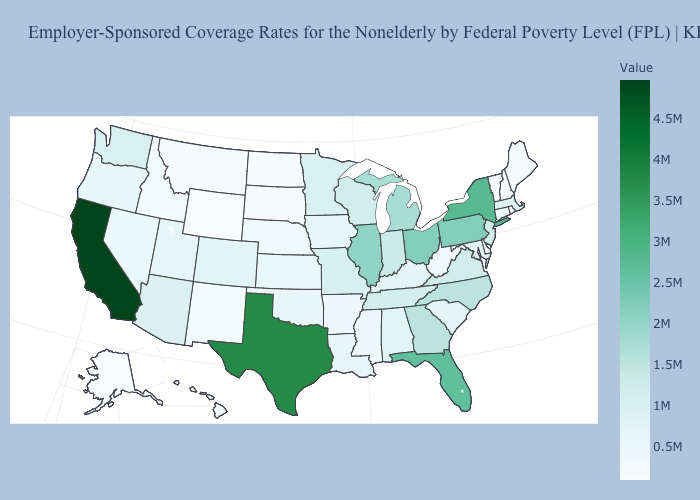Which states have the lowest value in the USA?
Concise answer only. Alaska. Does California have the highest value in the USA?
Quick response, please. Yes. Among the states that border Nevada , does California have the highest value?
Write a very short answer. Yes. Does Alabama have a higher value than Florida?
Be succinct. No. Does North Dakota have the lowest value in the MidWest?
Give a very brief answer. Yes. Does Texas have the highest value in the South?
Be succinct. Yes. Which states have the lowest value in the USA?
Give a very brief answer. Alaska. Does Connecticut have the highest value in the USA?
Write a very short answer. No. 